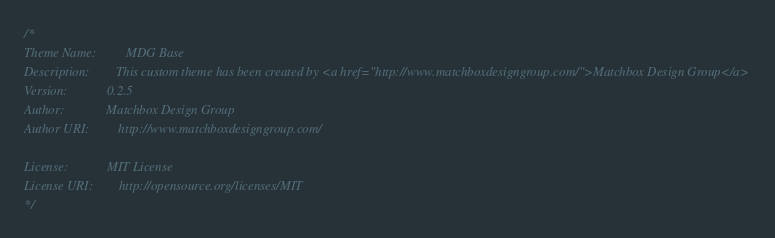Convert code to text. <code><loc_0><loc_0><loc_500><loc_500><_CSS_>/*
Theme Name:         MDG Base
Description:        This custom theme has been created by <a href="http://www.matchboxdesigngroup.com/">Matchbox Design Group</a>
Version:            0.2.5
Author:             Matchbox Design Group
Author URI:         http://www.matchboxdesigngroup.com/

License:            MIT License
License URI:        http://opensource.org/licenses/MIT
*/
</code> 